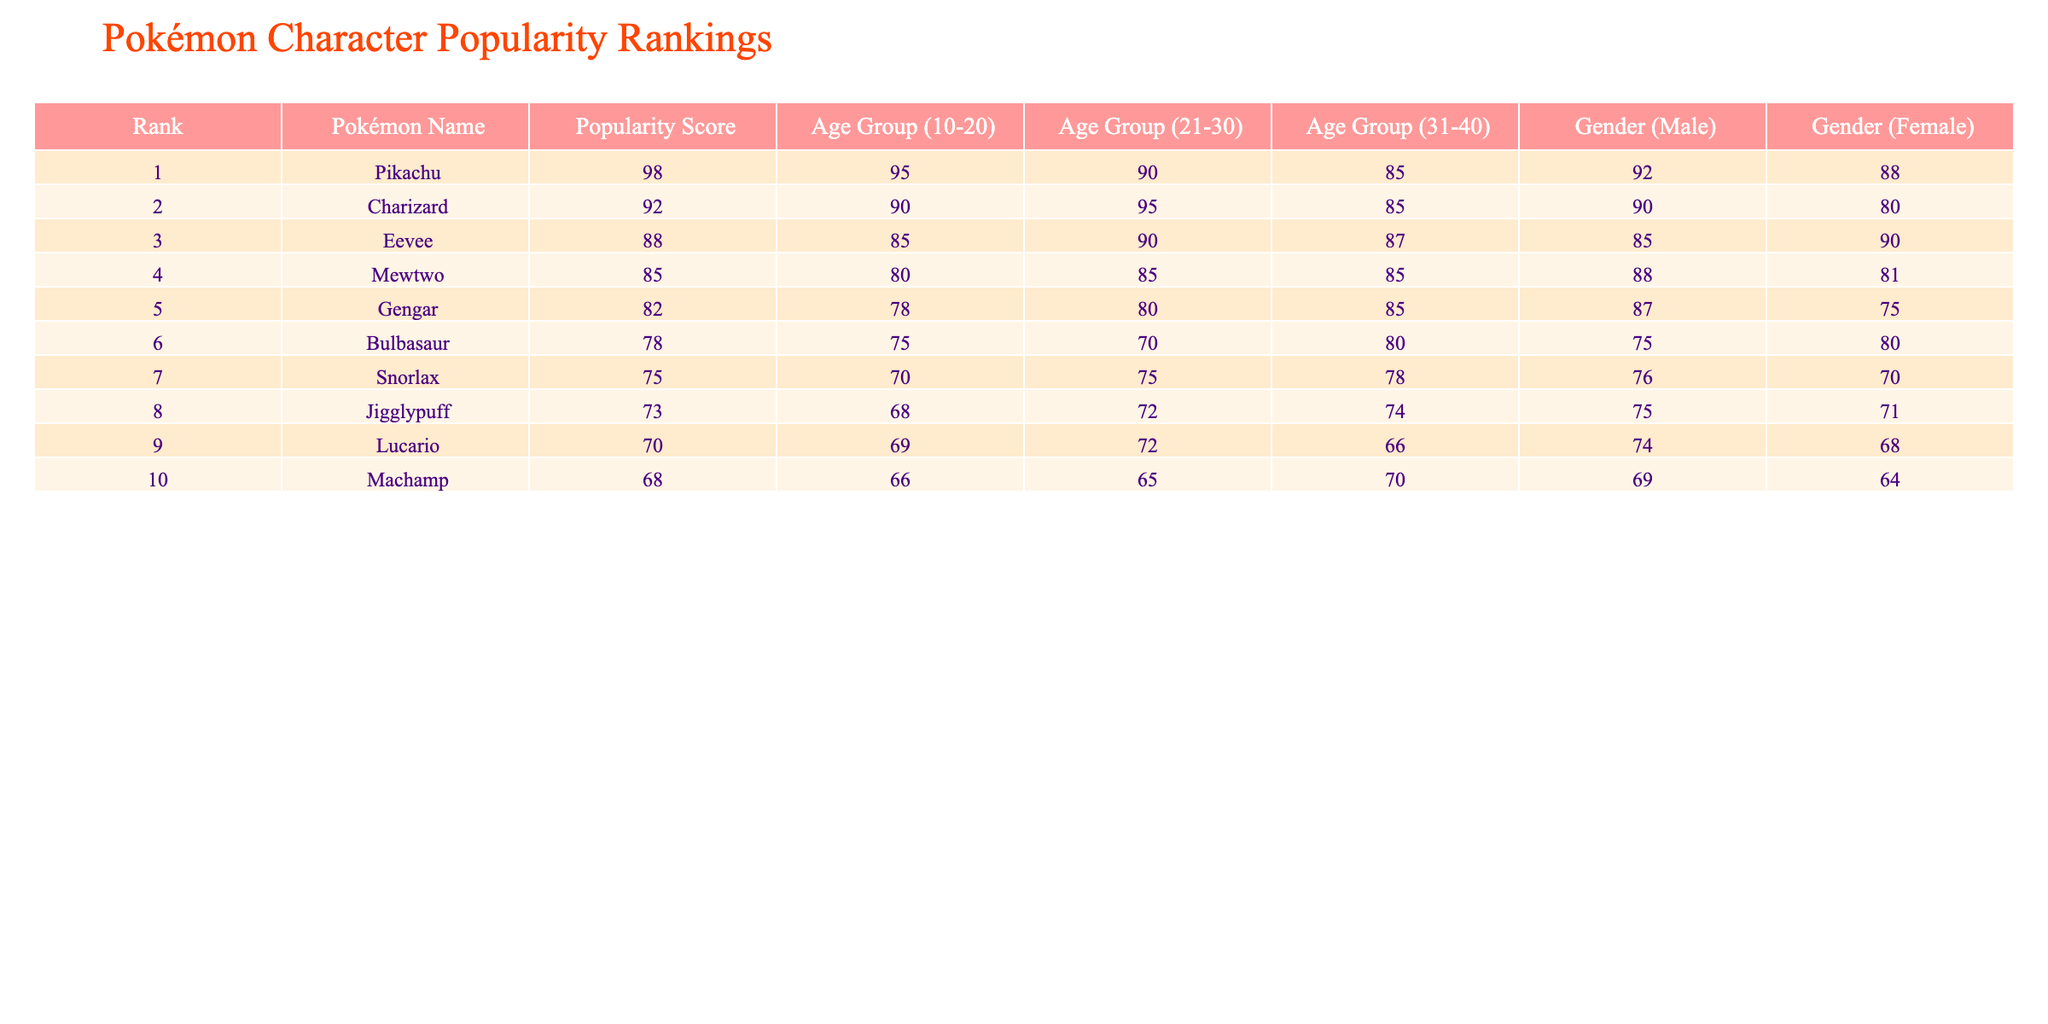What is the popularity score of Pikachu? Pikachu is ranked 1st in the table, and its popularity score is listed as 98.
Answer: 98 Which Pokémon has the highest popularity score among females? The table shows that Pikachu has a popularity score of 88 among females, which is the highest score compared to the other Pokémon listed.
Answer: Pikachu What is the average popularity score for the age group 31-40? To find the average score for the age group 31-40, we sum the scores: 85 (Mewtwo) + 87 (Eevee) + 85 (Gengar) + 80 (Bulbasaur) + 78 (Snorlax) + 72 (Lucario) + 65 (Machamp) = 542. There are 7 Pokémon, so the average is 542 / 7 = 77.43.
Answer: 77.43 Does Charizard have a higher popularity score among males than Eevee? By comparing the popularity scores for males, Charizard has 90 while Eevee has 85, indicating that Charizard does indeed have a higher score among males.
Answer: Yes Which Pokémon is the most popular among the age group 21-30? Looking at the data, Charizard has the highest score of 95 within the age group 21-30, making it the most popular Pokémon for that demographic.
Answer: Charizard What is the difference in popularity score between Gengar and Snorlax? Gengar has a popularity score of 82 and Snorlax has a score of 75. The difference is calculated as 82 - 75 = 7.
Answer: 7 Which Pokémon has the lowest popularity score and what is it? From the table, Machamp has the lowest popularity score at 68.
Answer: Machamp, 68 Is the popularity score for Bulbasaur lower than that of Jigglypuff among both genders? For males, Bulbasaur (80) is higher than Jigglypuff (74), but for females, Bulbasaur (75) is also higher than Jigglypuff (71). Hence, Bulbasaur is not lower than Jigglypuff in popularity scores for both genders.
Answer: No What is the total popularity score of the top three Pokémon? The top three Pokémon are Pikachu (98), Charizard (92), and Eevee (88). Summing these gives 98 + 92 + 88 = 278.
Answer: 278 